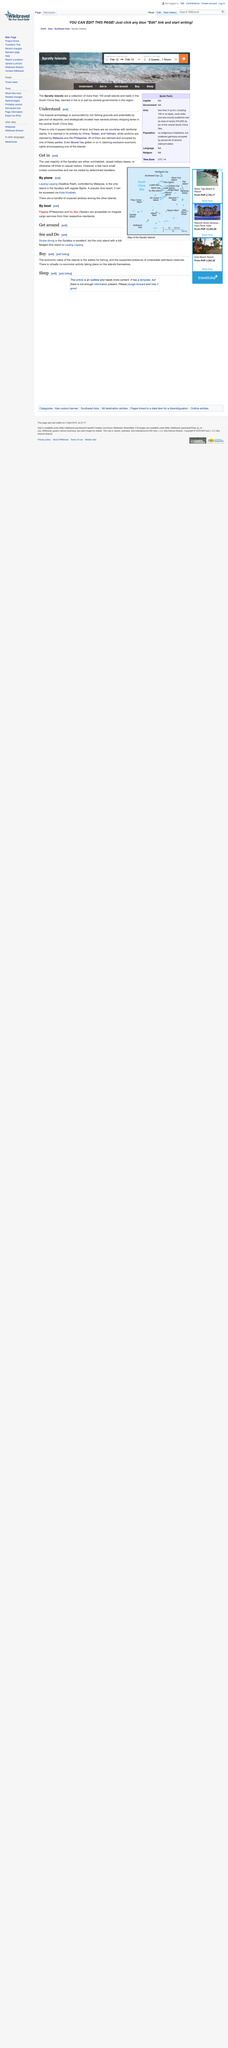Outline some significant characteristics in this image. The tropical archipelago consists of approximately four square kilometres of land. The tropical archipelago is subject to territorial claims by six countries, which are China, Taiwan, Vietnam, Malaysia, the Philippines, and Brunei. The Spratlys is the name of a tropical archipelago. 